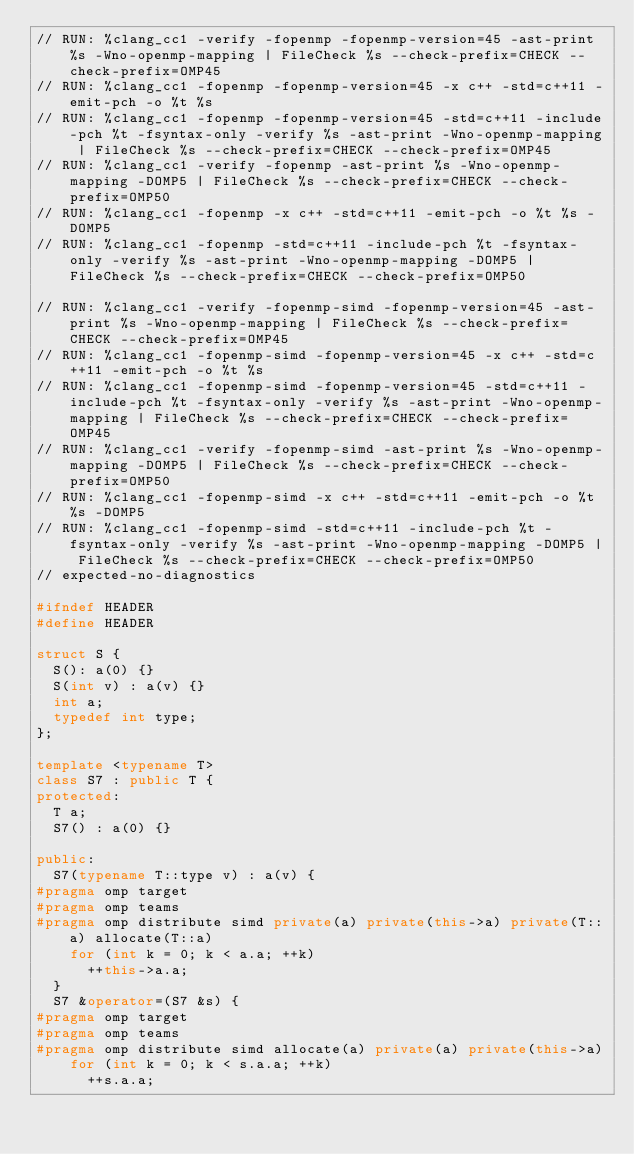<code> <loc_0><loc_0><loc_500><loc_500><_C++_>// RUN: %clang_cc1 -verify -fopenmp -fopenmp-version=45 -ast-print %s -Wno-openmp-mapping | FileCheck %s --check-prefix=CHECK --check-prefix=OMP45
// RUN: %clang_cc1 -fopenmp -fopenmp-version=45 -x c++ -std=c++11 -emit-pch -o %t %s
// RUN: %clang_cc1 -fopenmp -fopenmp-version=45 -std=c++11 -include-pch %t -fsyntax-only -verify %s -ast-print -Wno-openmp-mapping | FileCheck %s --check-prefix=CHECK --check-prefix=OMP45
// RUN: %clang_cc1 -verify -fopenmp -ast-print %s -Wno-openmp-mapping -DOMP5 | FileCheck %s --check-prefix=CHECK --check-prefix=OMP50
// RUN: %clang_cc1 -fopenmp -x c++ -std=c++11 -emit-pch -o %t %s -DOMP5
// RUN: %clang_cc1 -fopenmp -std=c++11 -include-pch %t -fsyntax-only -verify %s -ast-print -Wno-openmp-mapping -DOMP5 | FileCheck %s --check-prefix=CHECK --check-prefix=OMP50

// RUN: %clang_cc1 -verify -fopenmp-simd -fopenmp-version=45 -ast-print %s -Wno-openmp-mapping | FileCheck %s --check-prefix=CHECK --check-prefix=OMP45
// RUN: %clang_cc1 -fopenmp-simd -fopenmp-version=45 -x c++ -std=c++11 -emit-pch -o %t %s
// RUN: %clang_cc1 -fopenmp-simd -fopenmp-version=45 -std=c++11 -include-pch %t -fsyntax-only -verify %s -ast-print -Wno-openmp-mapping | FileCheck %s --check-prefix=CHECK --check-prefix=OMP45
// RUN: %clang_cc1 -verify -fopenmp-simd -ast-print %s -Wno-openmp-mapping -DOMP5 | FileCheck %s --check-prefix=CHECK --check-prefix=OMP50
// RUN: %clang_cc1 -fopenmp-simd -x c++ -std=c++11 -emit-pch -o %t %s -DOMP5
// RUN: %clang_cc1 -fopenmp-simd -std=c++11 -include-pch %t -fsyntax-only -verify %s -ast-print -Wno-openmp-mapping -DOMP5 | FileCheck %s --check-prefix=CHECK --check-prefix=OMP50
// expected-no-diagnostics

#ifndef HEADER
#define HEADER

struct S {
  S(): a(0) {}
  S(int v) : a(v) {}
  int a;
  typedef int type;
};

template <typename T>
class S7 : public T {
protected:
  T a;
  S7() : a(0) {}

public:
  S7(typename T::type v) : a(v) {
#pragma omp target
#pragma omp teams
#pragma omp distribute simd private(a) private(this->a) private(T::a) allocate(T::a)
    for (int k = 0; k < a.a; ++k)
      ++this->a.a;
  }
  S7 &operator=(S7 &s) {
#pragma omp target
#pragma omp teams
#pragma omp distribute simd allocate(a) private(a) private(this->a)
    for (int k = 0; k < s.a.a; ++k)
      ++s.a.a;</code> 